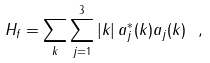<formula> <loc_0><loc_0><loc_500><loc_500>H _ { f } = \sum _ { k } \sum _ { j = 1 } ^ { 3 } | k | \, a ^ { * } _ { j } ( k ) a _ { j } ( k ) \ ,</formula> 